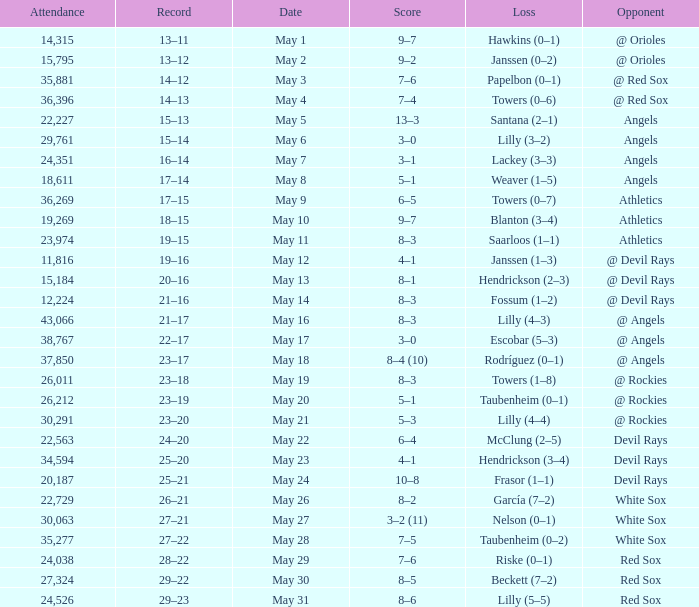When the team had their record of 16–14, what was the total attendance? 1.0. Help me parse the entirety of this table. {'header': ['Attendance', 'Record', 'Date', 'Score', 'Loss', 'Opponent'], 'rows': [['14,315', '13–11', 'May 1', '9–7', 'Hawkins (0–1)', '@ Orioles'], ['15,795', '13–12', 'May 2', '9–2', 'Janssen (0–2)', '@ Orioles'], ['35,881', '14–12', 'May 3', '7–6', 'Papelbon (0–1)', '@ Red Sox'], ['36,396', '14–13', 'May 4', '7–4', 'Towers (0–6)', '@ Red Sox'], ['22,227', '15–13', 'May 5', '13–3', 'Santana (2–1)', 'Angels'], ['29,761', '15–14', 'May 6', '3–0', 'Lilly (3–2)', 'Angels'], ['24,351', '16–14', 'May 7', '3–1', 'Lackey (3–3)', 'Angels'], ['18,611', '17–14', 'May 8', '5–1', 'Weaver (1–5)', 'Angels'], ['36,269', '17–15', 'May 9', '6–5', 'Towers (0–7)', 'Athletics'], ['19,269', '18–15', 'May 10', '9–7', 'Blanton (3–4)', 'Athletics'], ['23,974', '19–15', 'May 11', '8–3', 'Saarloos (1–1)', 'Athletics'], ['11,816', '19–16', 'May 12', '4–1', 'Janssen (1–3)', '@ Devil Rays'], ['15,184', '20–16', 'May 13', '8–1', 'Hendrickson (2–3)', '@ Devil Rays'], ['12,224', '21–16', 'May 14', '8–3', 'Fossum (1–2)', '@ Devil Rays'], ['43,066', '21–17', 'May 16', '8–3', 'Lilly (4–3)', '@ Angels'], ['38,767', '22–17', 'May 17', '3–0', 'Escobar (5–3)', '@ Angels'], ['37,850', '23–17', 'May 18', '8–4 (10)', 'Rodríguez (0–1)', '@ Angels'], ['26,011', '23–18', 'May 19', '8–3', 'Towers (1–8)', '@ Rockies'], ['26,212', '23–19', 'May 20', '5–1', 'Taubenheim (0–1)', '@ Rockies'], ['30,291', '23–20', 'May 21', '5–3', 'Lilly (4–4)', '@ Rockies'], ['22,563', '24–20', 'May 22', '6–4', 'McClung (2–5)', 'Devil Rays'], ['34,594', '25–20', 'May 23', '4–1', 'Hendrickson (3–4)', 'Devil Rays'], ['20,187', '25–21', 'May 24', '10–8', 'Frasor (1–1)', 'Devil Rays'], ['22,729', '26–21', 'May 26', '8–2', 'García (7–2)', 'White Sox'], ['30,063', '27–21', 'May 27', '3–2 (11)', 'Nelson (0–1)', 'White Sox'], ['35,277', '27–22', 'May 28', '7–5', 'Taubenheim (0–2)', 'White Sox'], ['24,038', '28–22', 'May 29', '7–6', 'Riske (0–1)', 'Red Sox'], ['27,324', '29–22', 'May 30', '8–5', 'Beckett (7–2)', 'Red Sox'], ['24,526', '29–23', 'May 31', '8–6', 'Lilly (5–5)', 'Red Sox']]} 